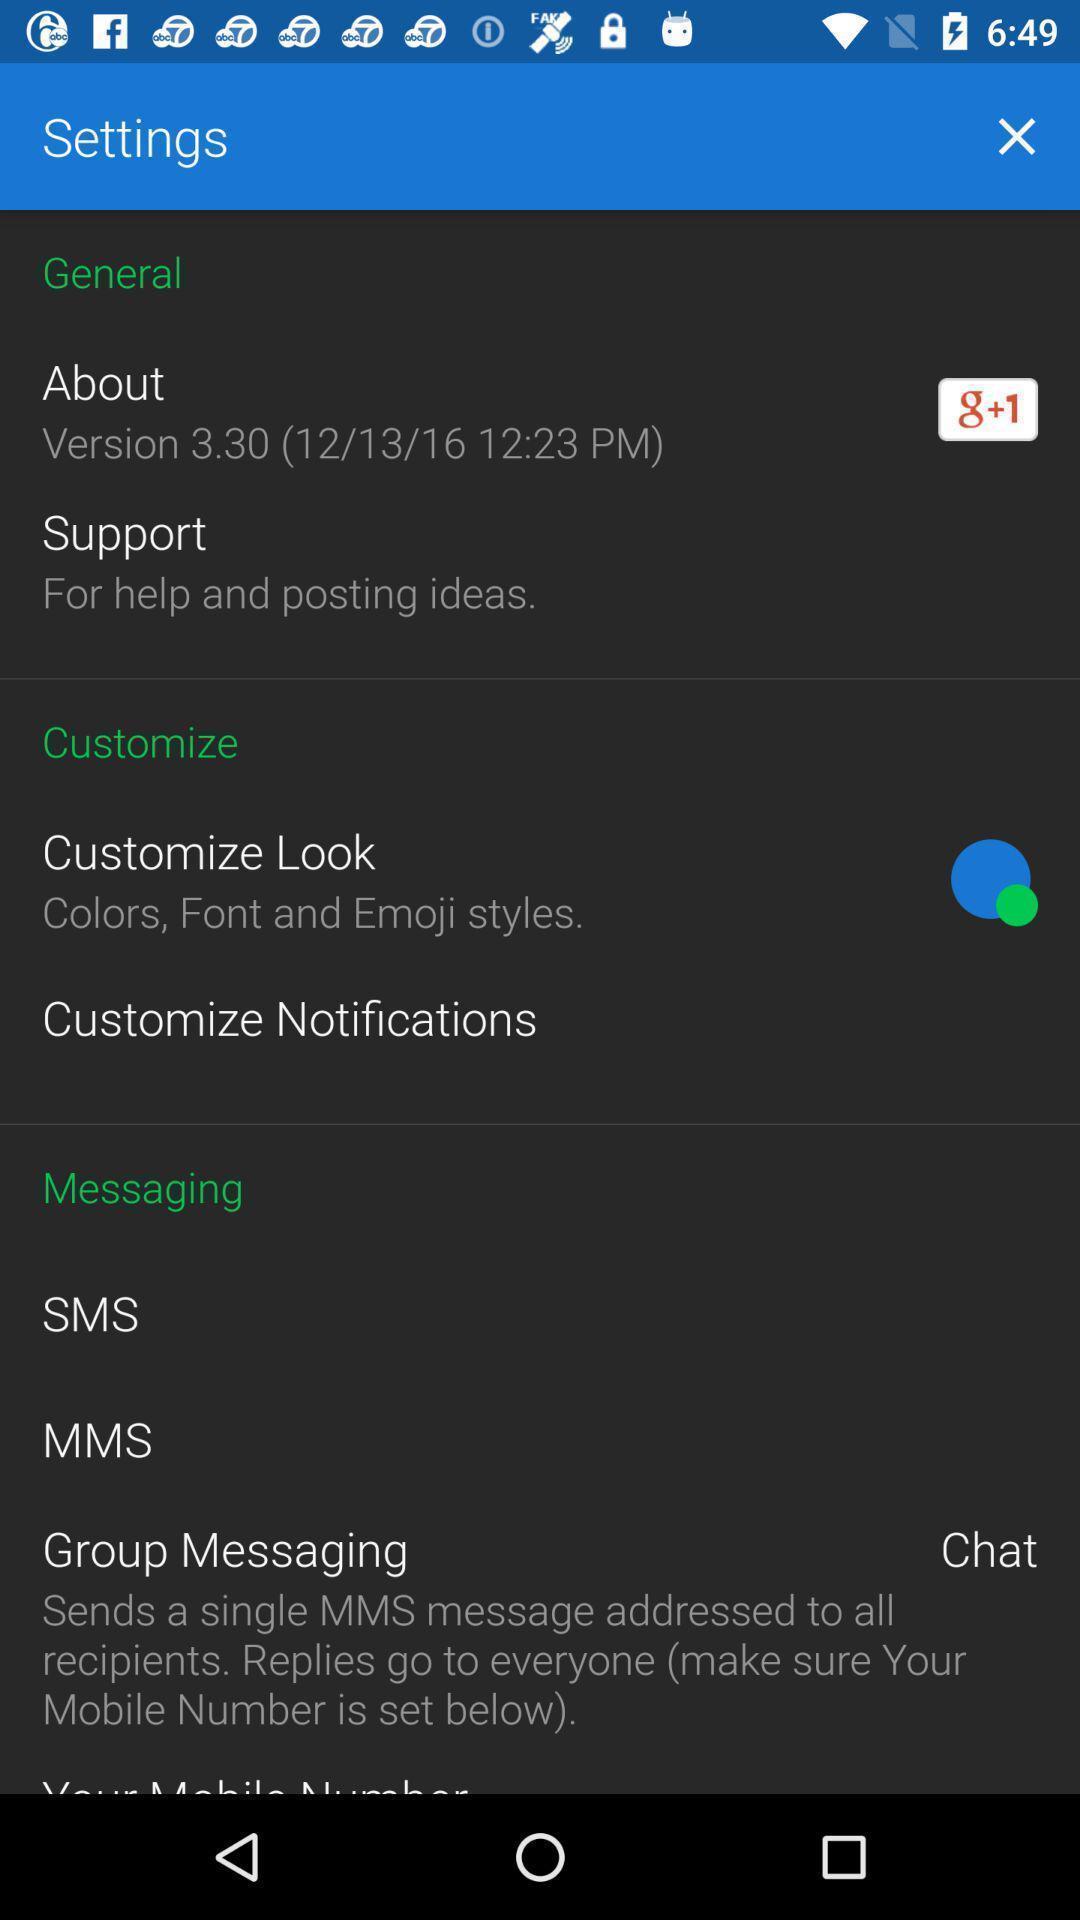Describe the content in this image. Settings page displayed. 